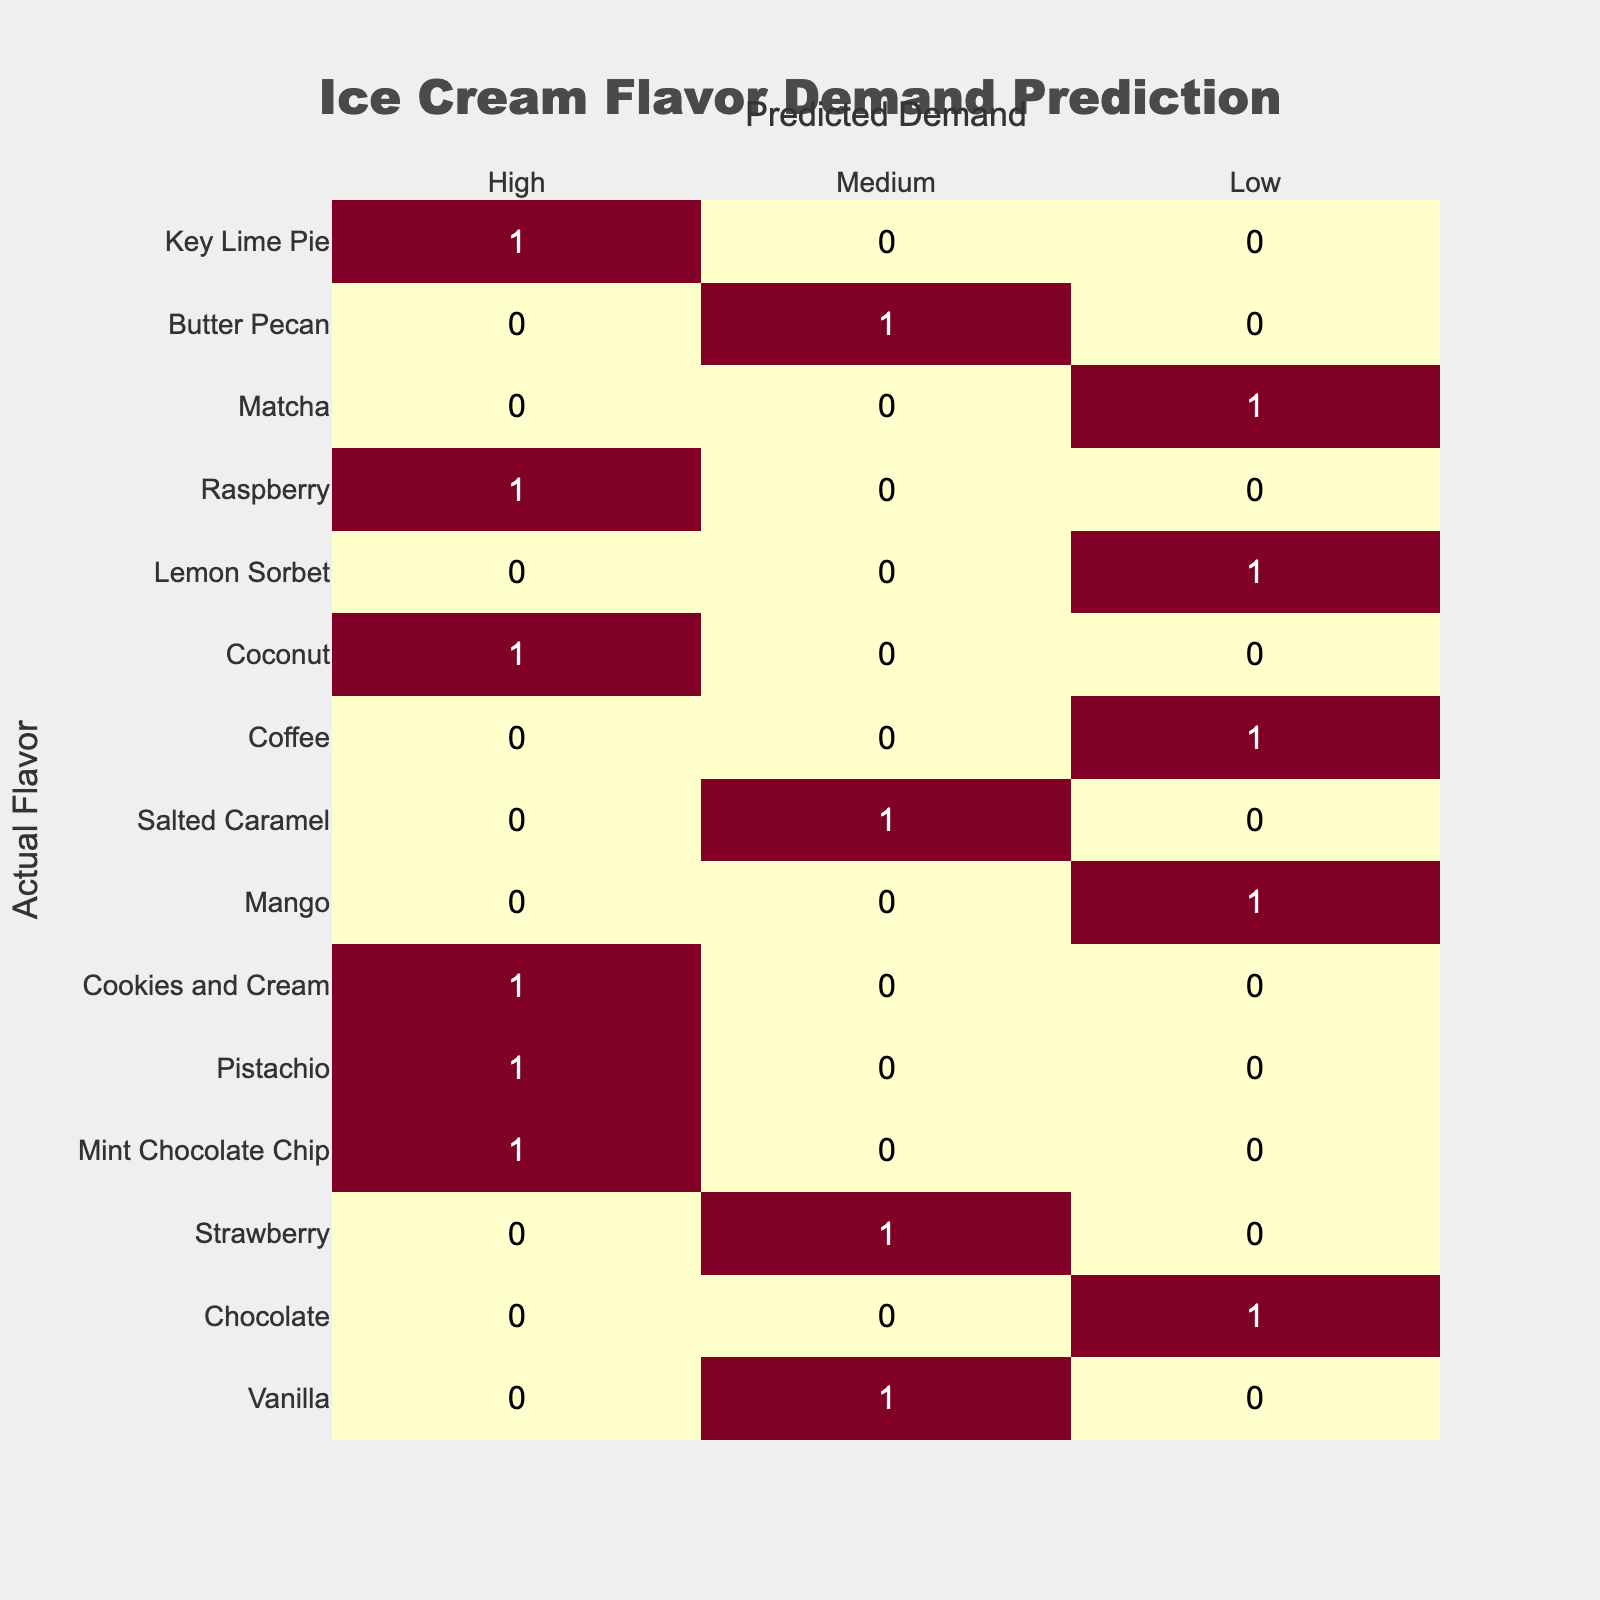What is the actual flavor with the highest predicted demand? Looking at the table, "Vanilla," "Mint Chocolate Chip," "Cookies and Cream," "Coffee," "Raspberry," and "Key Lime Pie" are predicted as "High." Among these, the actual flavor listed first is "Vanilla."
Answer: Vanilla How many actual flavors are predicted to have low demand? Referring to the table, the actual flavors predicted as "Low" are "Strawberry," "Mango," "Coconut," and "Butter Pecan." Counting these, there are 4 flavors.
Answer: 4 Is there any actual flavor that has a medium predicted demand? The table shows that "Chocolate," "Pistachio," "Salted Caramel," "Lemon Sorbet," and "Matcha" have a predicted demand of "Medium." Since there are flavors listed, the answer is yes.
Answer: Yes What is the total count of actual flavors listed in the "High" category? The flavors predicted as "High" are "Vanilla," "Mint Chocolate Chip," "Cookies and Cream," "Coffee," "Raspberry," and "Key Lime Pie." Counting these gives a total of 6 flavors in this category.
Answer: 6 Which actual flavor has the lowest predicted demand? In the table, the flavors with "Low" predicted demand are "Strawberry," "Mango," "Coconut," and "Butter Pecan." The flavor listed first among these is "Strawberry," so it is the lowest.
Answer: Strawberry How many flavors are predicted to have either low or medium demand? The predicted demands are "Low" for 4 flavors ("Strawberry," "Mango," "Coconut," "Butter Pecan") and "Medium" for 5 flavors ("Chocolate," "Pistachio," "Salted Caramel," "Lemon Sorbet," "Matcha"). Summing these gives 4 + 5 = 9 flavors.
Answer: 9 Are there more flavors with high demand or medium demand? High predicted demand includes 6 flavors ("Vanilla," "Mint Chocolate Chip," "Cookies and Cream," "Coffee," "Raspberry," "Key Lime Pie") while medium predicted demand has 5 flavors ("Chocolate," "Pistachio," "Salted Caramel," "Lemon Sorbet," "Matcha"). Since 6 is greater than 5, the answer is yes.
Answer: Yes What is the difference in the count of flavors between high and low predicted demand? High demand has 6 flavors ("Vanilla," "Mint Chocolate Chip," "Cookies and Cream," "Coffee," "Raspberry," "Key Lime Pie") while low demand has 4 flavors ("Strawberry," "Mango," "Coconut," "Butter Pecan"). The difference is 6 - 4 = 2.
Answer: 2 Which predicted demand category has the largest variety of actual flavors? Evaluating the counts, high demand has 6 flavors and low demand has 4. Medium demand has 5. The high category has the most variety, with 6 flavors.
Answer: High 